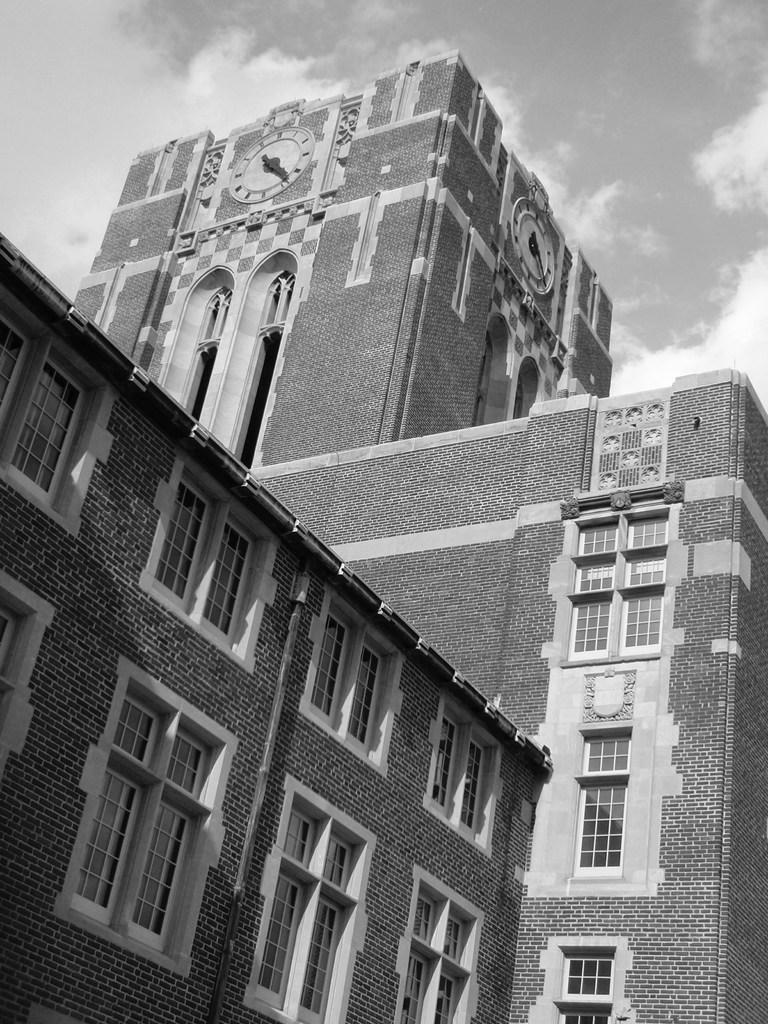Please provide a concise description of this image. In this picture we can see clocks on the building, and also we can see clouds. 